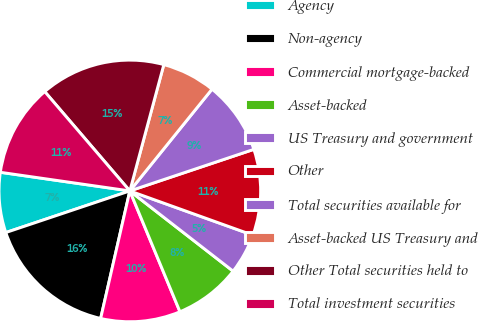<chart> <loc_0><loc_0><loc_500><loc_500><pie_chart><fcel>Agency<fcel>Non-agency<fcel>Commercial mortgage-backed<fcel>Asset-backed<fcel>US Treasury and government<fcel>Other<fcel>Total securities available for<fcel>Asset-backed US Treasury and<fcel>Other Total securities held to<fcel>Total investment securities<nl><fcel>7.43%<fcel>16.27%<fcel>9.84%<fcel>8.23%<fcel>5.02%<fcel>10.64%<fcel>9.04%<fcel>6.63%<fcel>15.46%<fcel>11.45%<nl></chart> 